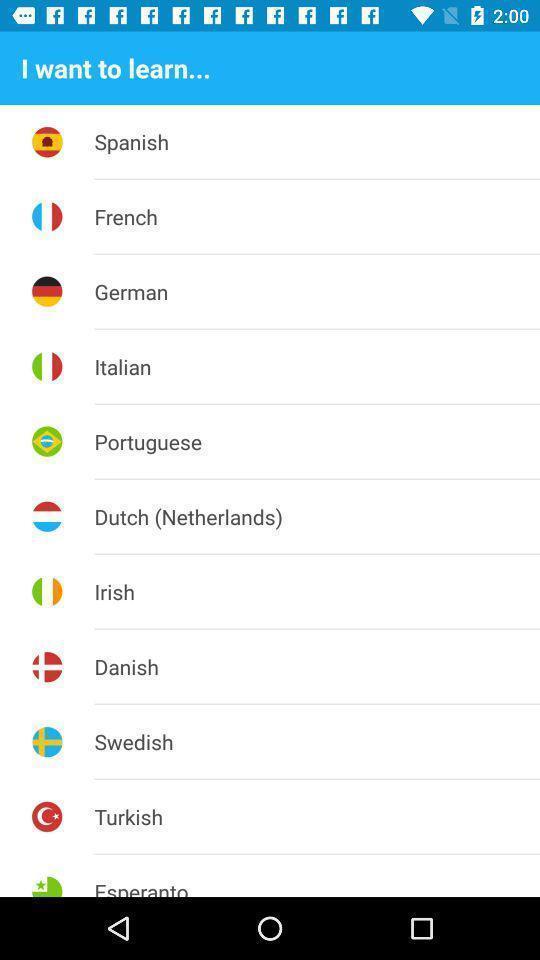What can you discern from this picture? Page shows different countries and logos in learning application. 